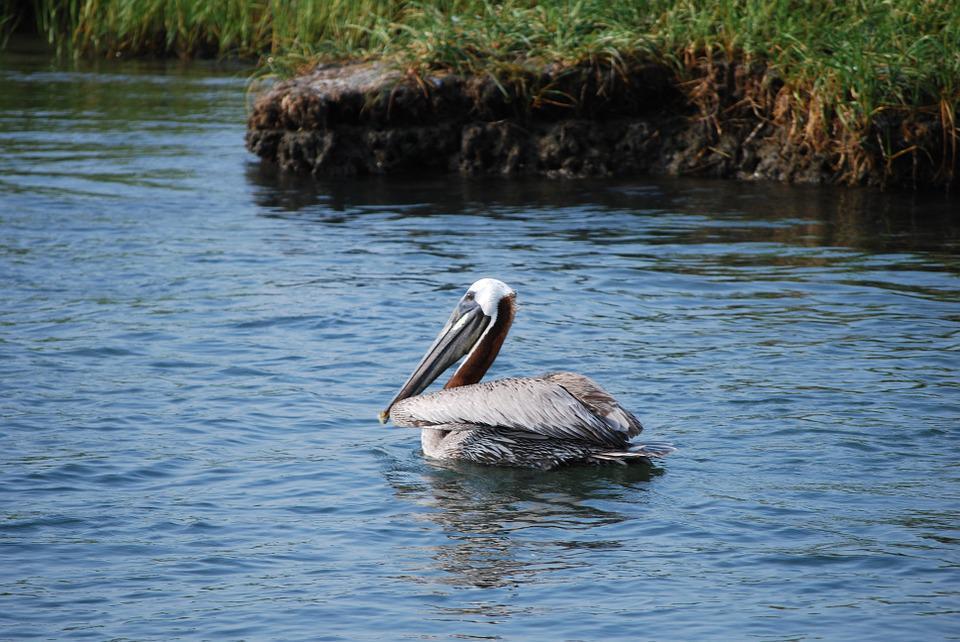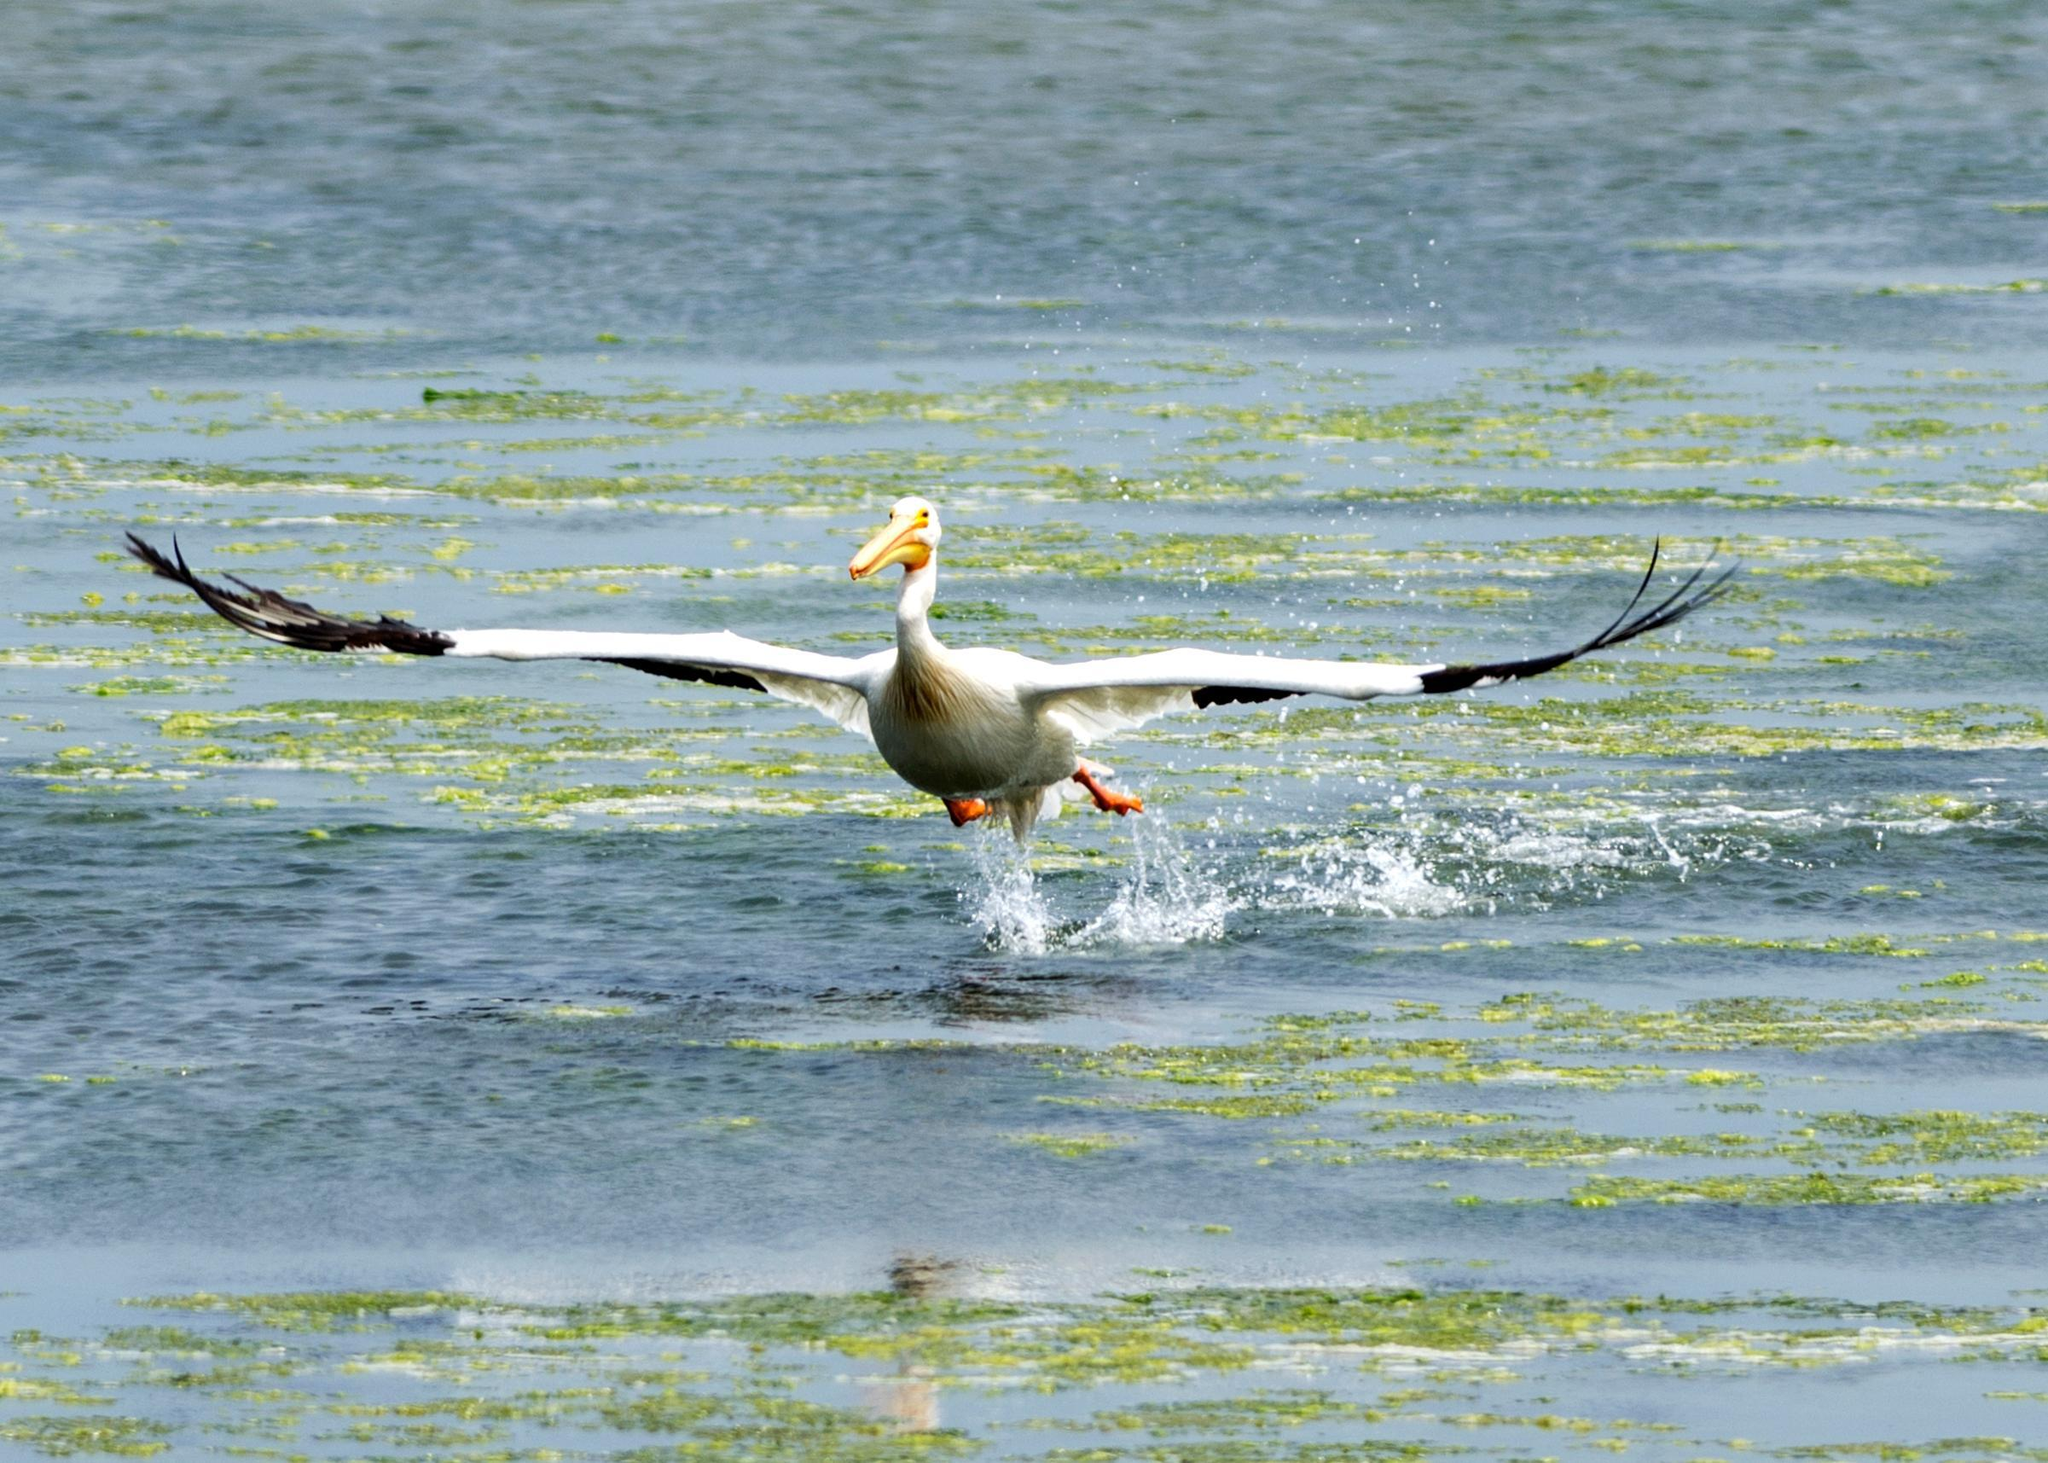The first image is the image on the left, the second image is the image on the right. Given the left and right images, does the statement "There are 2 adult pelicans and 1 baby pelican in the water." hold true? Answer yes or no. No. 